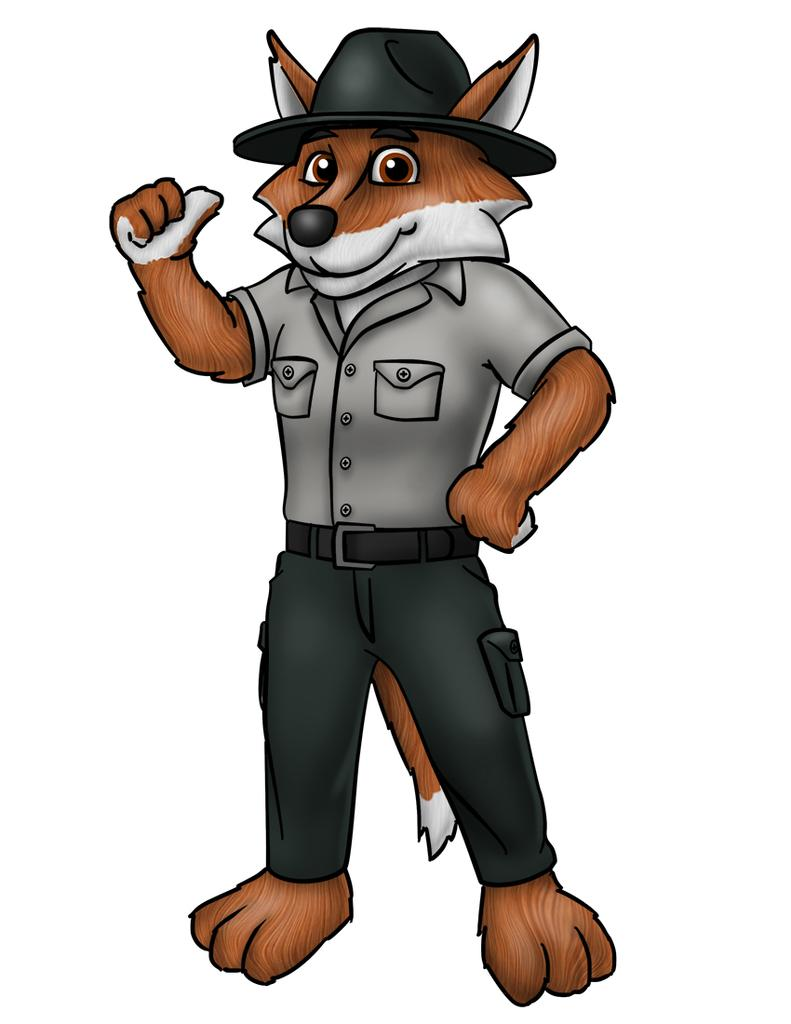What type of image is this? The image is animated. What animal is present in the image? There is a fox in the image. How is the fox positioned in the image? The fox is standing. What clothing items is the fox wearing? The fox is wearing a shirt, trousers, a belt, and a hat. What color is the crayon that the fox is holding in the image? There is no crayon present in the image. What type of wool is used to make the fox's hat in the image? The image is animated, and the fox is not wearing a hat made of wool. 